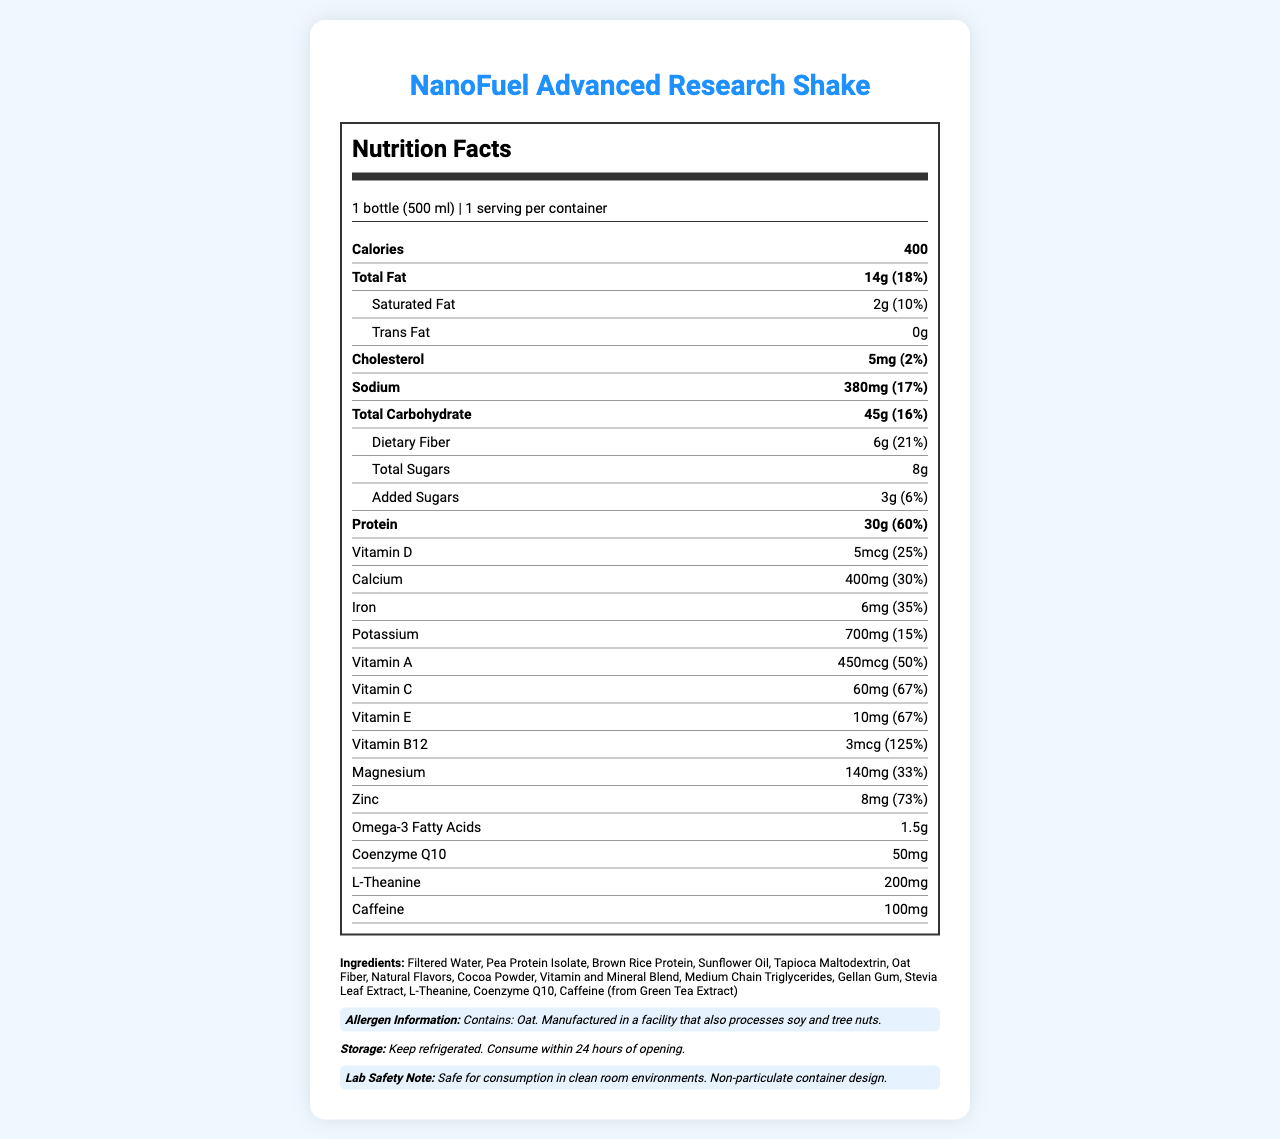what is the serving size of NanoFuel Advanced Research Shake? The serving size is clearly mentioned on the document as "1 bottle (500 ml)".
Answer: 1 bottle (500 ml) how many calories are in one bottle of this shake? The document states that the shake contains 400 calories per serving.
Answer: 400 what is the amount of total fat in the shake? The nutritional facts label mentions that the total fat content is 14g, which constitutes 18% of the daily value.
Answer: 14g (18%) how much sodium does one serving contain? The document shows that one serving of the shake contains 380mg of sodium, which is 17% of the daily value.
Answer: 380mg (17%) which vitamin has the highest daily value percentage in this shake? The nutrition facts show that Vitamin B12 has a daily value percentage of 125%, which is the highest among all listed vitamins and minerals.
Answer: Vitamin B12 how much dietary fiber is in one serving? A. 3g B. 6g C. 10g D. 12g The document states there is 6g of dietary fiber in one serving (21% of daily value).
Answer: B what is the percentage of daily value for calcium provided by the shake? A. 20% B. 25% C. 30% D. 35% The nutrition facts indicate the shake provides 30% of the daily value for calcium.
Answer: C is this shake high in protein? The document shows that the shake contains 30g of protein, which is 60% of the daily value, making it high in protein.
Answer: Yes describe the main idea of the document. The document includes a comprehensive breakdown of the nutrients and their respective daily values found in the NanoFuel Advanced Research Shake, along with additional information about its ingredients, potential allergens, recommended storage conditions, and a note on lab safety.
Answer: The document provides the nutritional information for NanoFuel Advanced Research Shake, detailing the nutrient content, daily value percentages, ingredients, allergen information, storage instructions, and lab safety note. what is the source of the caffeine in the shake? The list of ingredients shows that the caffeine comes from Green Tea Extract.
Answer: Green Tea Extract are there any added sugars in the shake? The document indicates that the shake contains 3g of added sugars, which is 6% of the daily value.
Answer: Yes how should the shake be stored after opening? The storage instructions clearly state the shake should be kept refrigerated and consumed within 24 hours of opening.
Answer: Keep refrigerated. Consume within 24 hours of opening. is the shake safe to consume in clean room environments? The lab safety note states that it is safe for consumption in clean room environments.
Answer: Yes what is the main ingredient in the shake? The ingredients list begins with "Filtered Water," indicating it is the main ingredient.
Answer: Filtered Water what is the amount of iron in the shake? According to the nutrition facts, the shake contains 6mg of iron, which translates to 35% of the daily value.
Answer: 6mg (35%) does the shake contain any tree nuts? The allergen information states that the product is manufactured in a facility that processes tree nuts, but it does not confirm whether the shake itself contains tree nuts.
Answer: Cannot be determined 